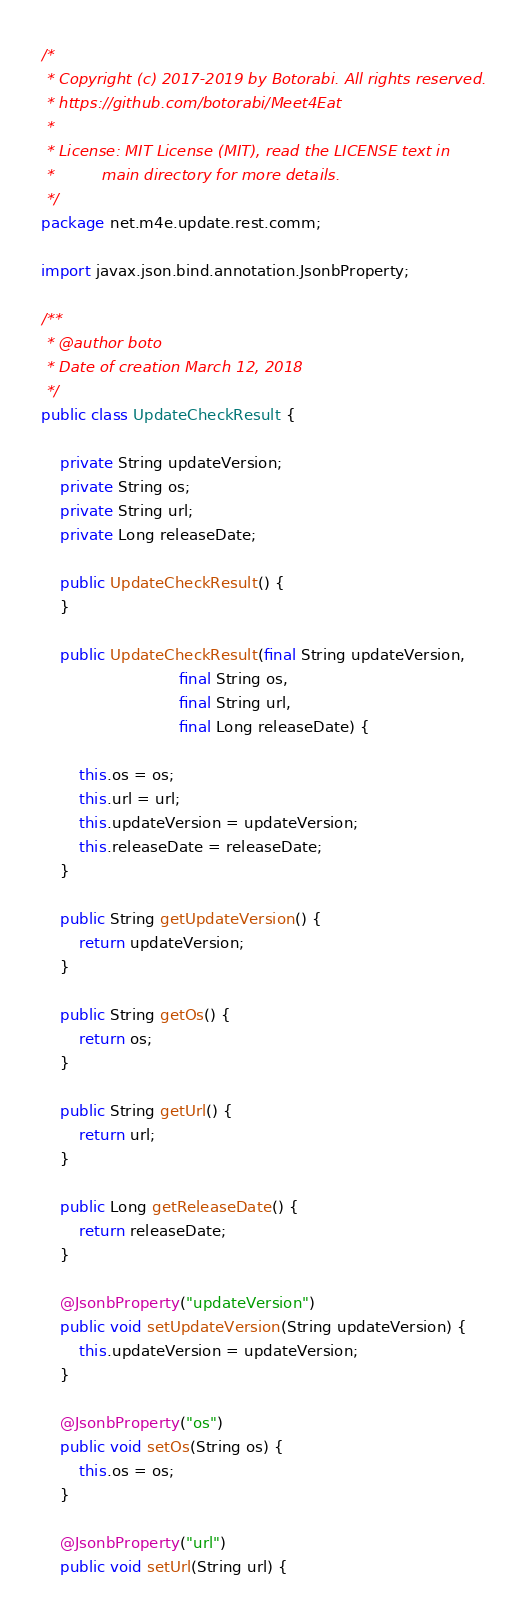<code> <loc_0><loc_0><loc_500><loc_500><_Java_>/*
 * Copyright (c) 2017-2019 by Botorabi. All rights reserved.
 * https://github.com/botorabi/Meet4Eat
 *
 * License: MIT License (MIT), read the LICENSE text in
 *          main directory for more details.
 */
package net.m4e.update.rest.comm;

import javax.json.bind.annotation.JsonbProperty;

/**
 * @author boto
 * Date of creation March 12, 2018
 */
public class UpdateCheckResult {

    private String updateVersion;
    private String os;
    private String url;
    private Long releaseDate;

    public UpdateCheckResult() {
    }

    public UpdateCheckResult(final String updateVersion,
                             final String os,
                             final String url,
                             final Long releaseDate) {

        this.os = os;
        this.url = url;
        this.updateVersion = updateVersion;
        this.releaseDate = releaseDate;
    }

    public String getUpdateVersion() {
        return updateVersion;
    }

    public String getOs() {
        return os;
    }

    public String getUrl() {
        return url;
    }

    public Long getReleaseDate() {
        return releaseDate;
    }

    @JsonbProperty("updateVersion")
    public void setUpdateVersion(String updateVersion) {
        this.updateVersion = updateVersion;
    }

    @JsonbProperty("os")
    public void setOs(String os) {
        this.os = os;
    }

    @JsonbProperty("url")
    public void setUrl(String url) {</code> 